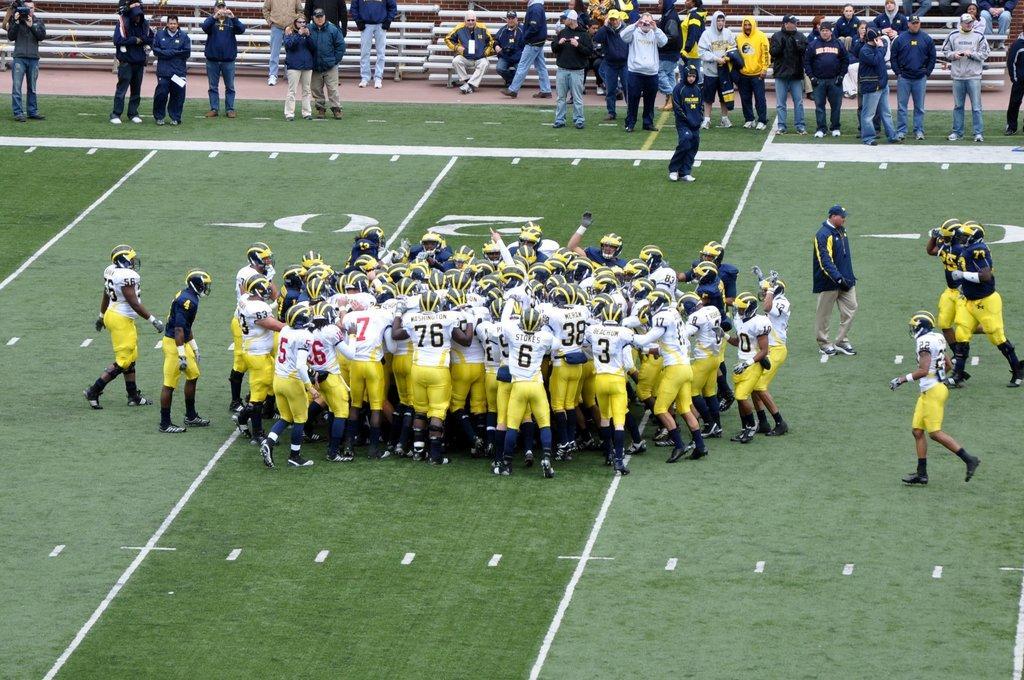Can you describe this image briefly? In this picture I can see the ground, on which there are number of people who are wearing jerseys and helmets and I see the white color lines. In the background I see few more people and I see the benches. 